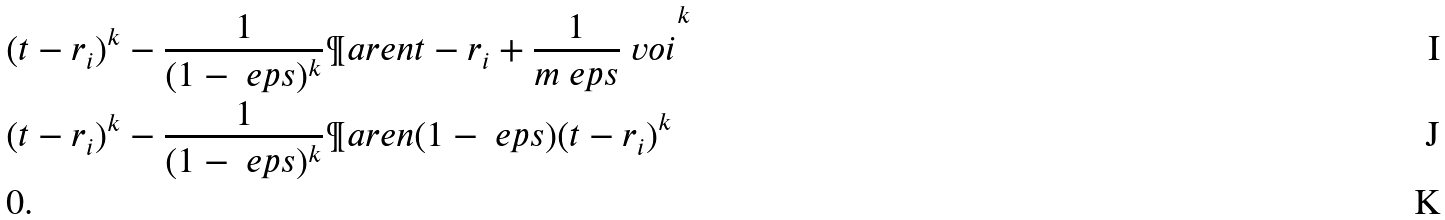<formula> <loc_0><loc_0><loc_500><loc_500>& ( t - r _ { i } ) ^ { k } - \frac { 1 } { ( 1 - \ e p s ) ^ { k } } \P a r e n { t - r _ { i } + \frac { 1 } { m \ e p s } \ v o { i } } ^ { k } \\ & ( t - r _ { i } ) ^ { k } - \frac { 1 } { ( 1 - \ e p s ) ^ { k } } \P a r e n { ( 1 - \ e p s ) ( t - r _ { i } ) } ^ { k } \\ & 0 .</formula> 